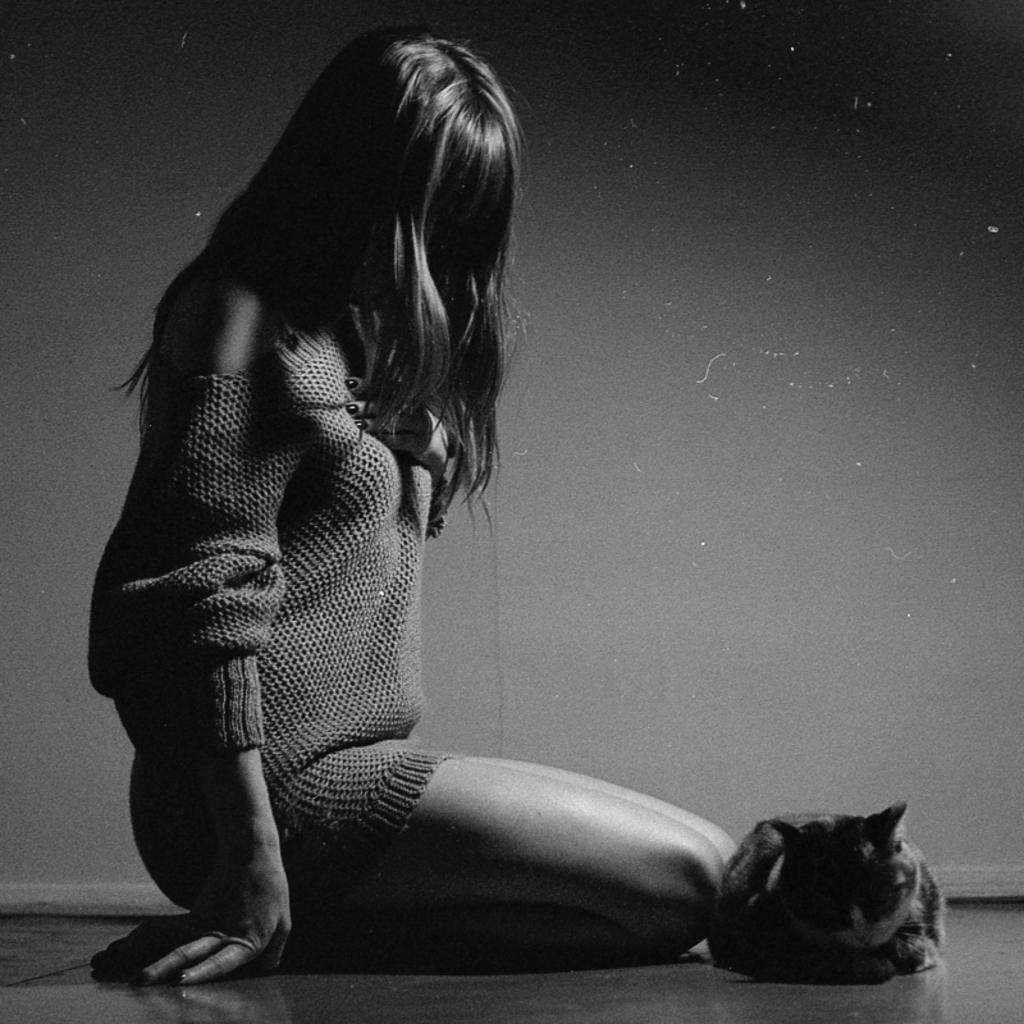Who is the main subject in the image? There is a girl in the image. What is the girl wearing? The girl is wearing a sweatshirt. Where is the girl sitting? The girl is sitting on the floor. What other living creature is present in the image? There is a cat in the image. Where is the cat sitting? The cat is sitting on the floor. What type of bun is the girl eating in the image? There is no bun present in the image; the girl is wearing a sweatshirt and sitting on the floor. 